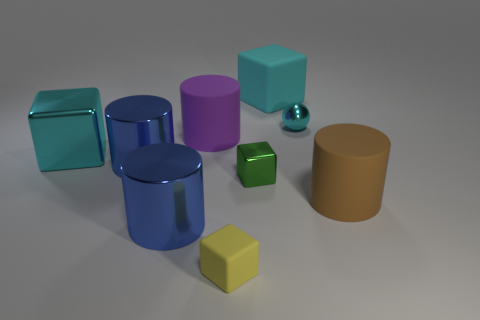What number of other objects are the same color as the large matte cube?
Your response must be concise. 2. Does the cyan object left of the yellow thing have the same material as the cube in front of the big brown rubber thing?
Provide a succinct answer. No. Is the number of large objects that are to the right of the cyan ball the same as the number of cyan metal spheres that are to the left of the green shiny cube?
Offer a very short reply. No. There is a big block that is on the right side of the small yellow matte object; what is its material?
Ensure brevity in your answer.  Rubber. Are there fewer brown rubber things than blue rubber things?
Offer a very short reply. No. There is a matte thing that is both on the left side of the metallic sphere and in front of the large cyan metallic thing; what shape is it?
Keep it short and to the point. Cube. How many big blue objects are there?
Ensure brevity in your answer.  2. The cyan thing that is left of the thing behind the metal thing right of the cyan rubber block is made of what material?
Provide a short and direct response. Metal. What number of balls are to the left of the large cylinder right of the shiny ball?
Provide a succinct answer. 1. The other shiny object that is the same shape as the green object is what color?
Offer a very short reply. Cyan. 